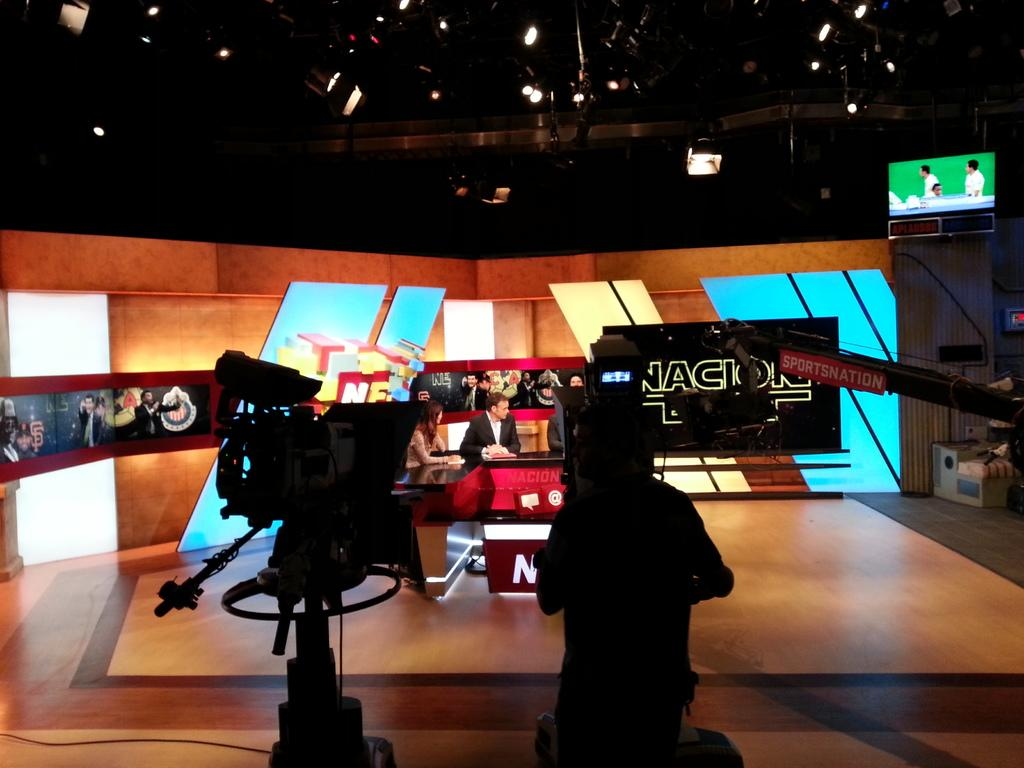<image>
Relay a brief, clear account of the picture shown. The backstage area for the studio set for sportsnation is shown. 